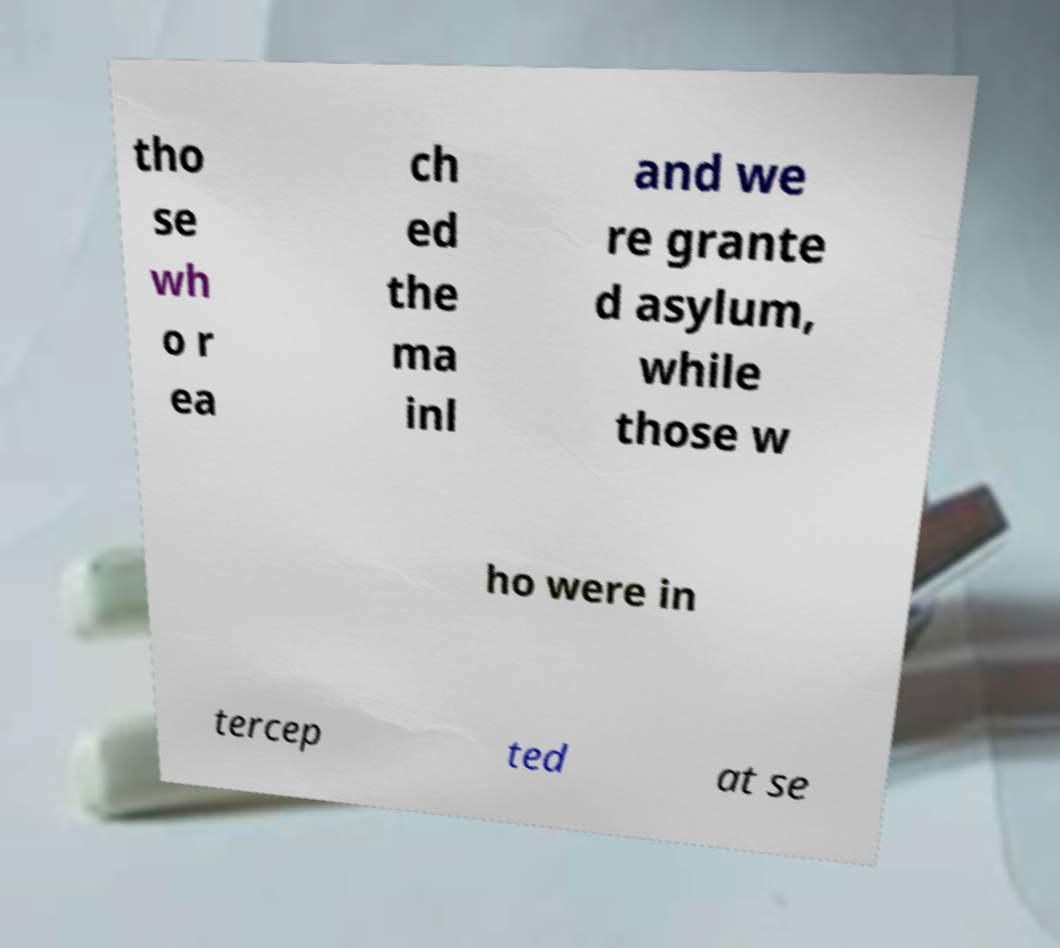Can you read and provide the text displayed in the image?This photo seems to have some interesting text. Can you extract and type it out for me? tho se wh o r ea ch ed the ma inl and we re grante d asylum, while those w ho were in tercep ted at se 